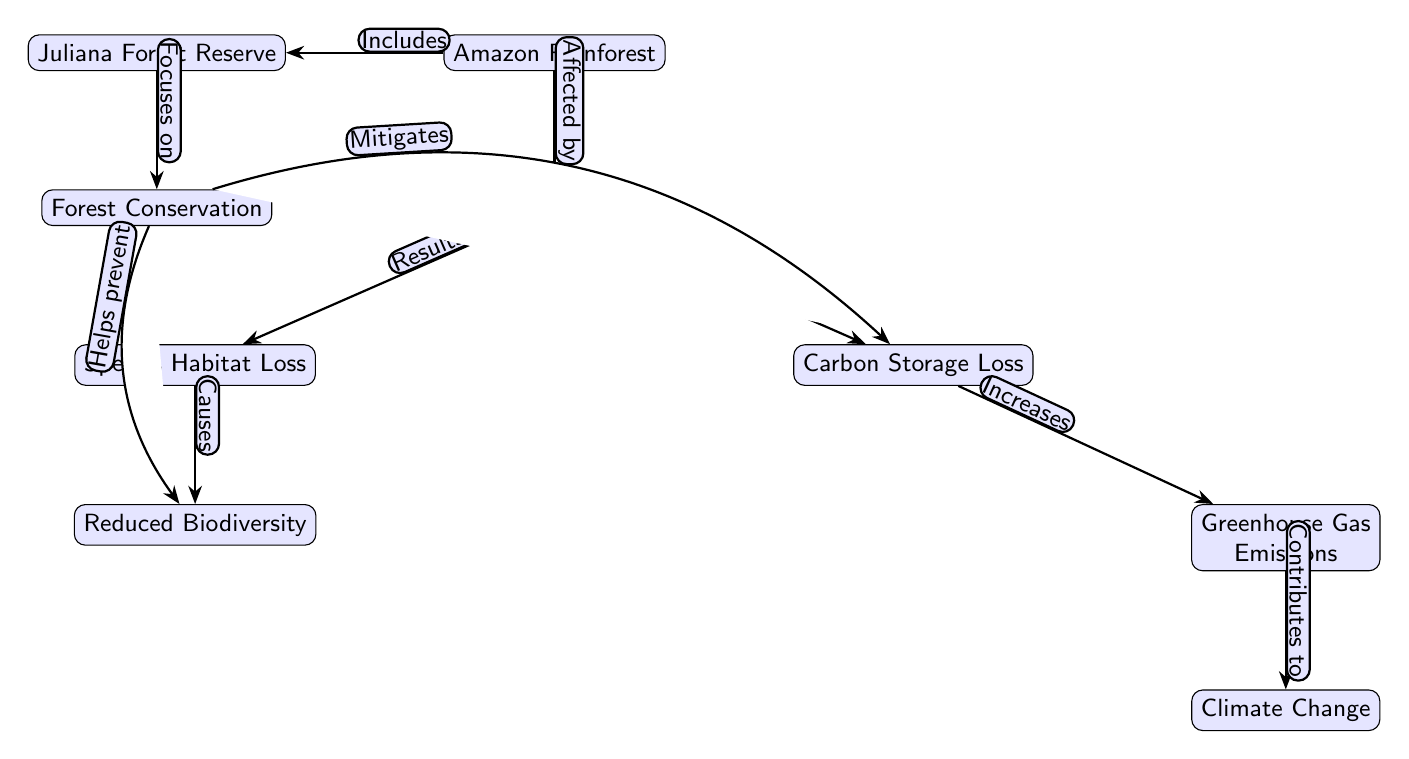What node is directly affected by Deforestation? The diagram indicates that the node "Deforestation" has an edge that connects to the "Amazon Rainforest," marking it as directly affected.
Answer: Amazon Rainforest How many nodes represent negative impacts of Deforestation? The diagram features three nodes that represent negative impacts of Deforestation: "Carbon Storage Loss," "Species Habitat Loss," and "Reduced Biodiversity."
Answer: 3 What action does Forest Conservation help prevent? The diagram shows that there is an edge from "Forest Conservation" to "Reduced Biodiversity," indicating that Forest Conservation helps prevent reduced biodiversity.
Answer: Reduced Biodiversity What consequence is indicated by the increase in Greenhouse Gas Emissions? The diagram shows that "Greenhouse Gas Emissions" is linked to "Climate Change," signifying that an increase in Greenhouse Gas Emissions contributes to Climate Change.
Answer: Climate Change Which node includes Juliana Forest Reserve? Upon examining the connections, "Amazon Rainforest" is the node that includes "Juliana Forest Reserve," as depicted in the diagram.
Answer: Amazon Rainforest What two consequences are directly linked to Deforestation? The diagram outlines that Deforestation leads to "Carbon Storage Loss" and "Species Habitat Loss," highlighting two direct consequences.
Answer: Carbon Storage Loss and Species Habitat Loss What effect does Forest Conservation have on Carbon Storage Loss? The diagram shows a bent edge from "Forest Conservation" to "Carbon Storage Loss," which states that Forest Conservation mitigates Carbon Storage Loss.
Answer: Mitigates How does Carbon Storage Loss affect Greenhouse Gas Emissions? According to the diagram, "Carbon Storage Loss" is connected to "Greenhouse Gas Emissions" with an edge indicating that Carbon Storage Loss increases Greenhouse Gas Emissions.
Answer: Increases What is the relationship between Species Habitat Loss and Reduced Biodiversity? The diagram suggests that "Species Habitat Loss" leads to "Reduced Biodiversity," indicating a direct relationship where habitat loss causes reduced species variety.
Answer: Causes 